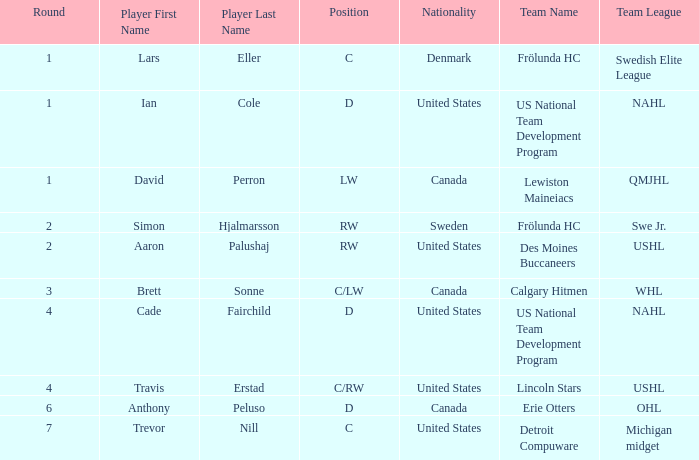Give me the full table as a dictionary. {'header': ['Round', 'Player First Name', 'Player Last Name', 'Position', 'Nationality', 'Team Name', 'Team League'], 'rows': [['1', 'Lars', 'Eller', 'C', 'Denmark', 'Frölunda HC', 'Swedish Elite League'], ['1', 'Ian', 'Cole', 'D', 'United States', 'US National Team Development Program', 'NAHL'], ['1', 'David', 'Perron', 'LW', 'Canada', 'Lewiston Maineiacs', 'QMJHL'], ['2', 'Simon', 'Hjalmarsson', 'RW', 'Sweden', 'Frölunda HC', 'Swe Jr.'], ['2', 'Aaron', 'Palushaj', 'RW', 'United States', 'Des Moines Buccaneers', 'USHL'], ['3', 'Brett', 'Sonne', 'C/LW', 'Canada', 'Calgary Hitmen', 'WHL'], ['4', 'Cade', 'Fairchild', 'D', 'United States', 'US National Team Development Program', 'NAHL'], ['4', 'Travis', 'Erstad', 'C/RW', 'United States', 'Lincoln Stars', 'USHL'], ['6', 'Anthony', 'Peluso', 'D', 'Canada', 'Erie Otters', 'OHL'], ['7', 'Trevor', 'Nill', 'C', 'United States', 'Detroit Compuware', 'Michigan midget']]} Who is the player from Denmark who plays position c? Lars Eller. 